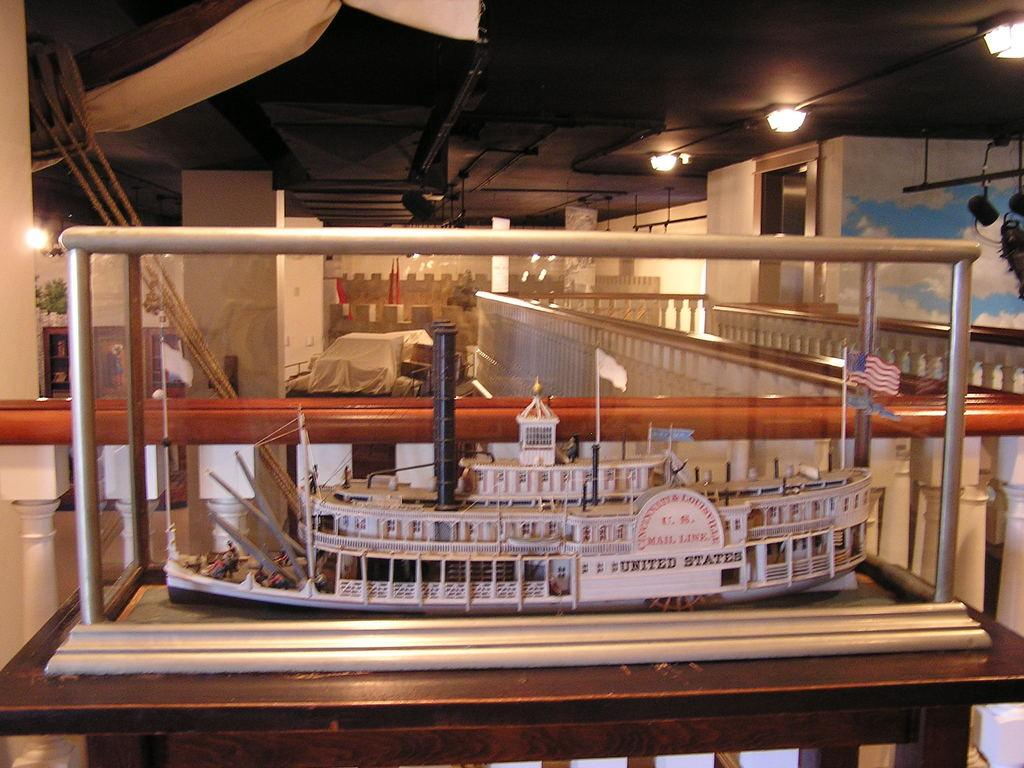What is the main object in the image? There is a toy ship in the image. Where is the toy ship located? The toy ship is placed in a box. What is at the bottom of the image? There is a table at the bottom of the image. What can be seen in the background of the image? In the background, there is a cloth, ropes, walls, a door, and lights. What type of hearing aid is visible in the image? There is no hearing aid present in the image. How does the selection of toys affect the arrangement of the toy ship in the image? The image does not show a selection of toys, so it cannot be determined how it would affect the arrangement of the toy ship. 